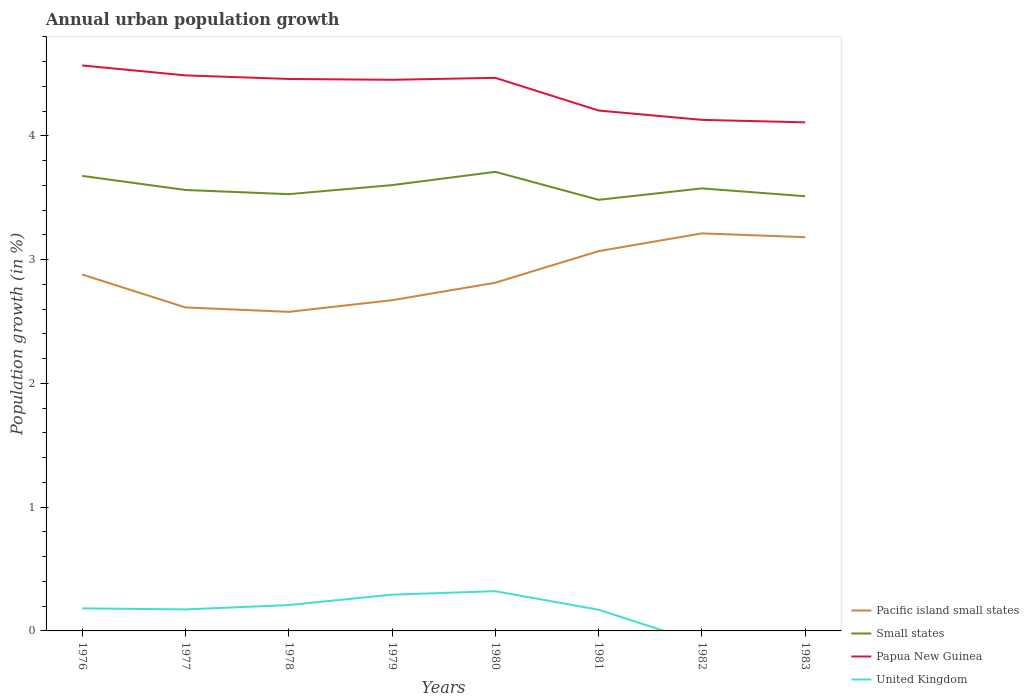How many different coloured lines are there?
Keep it short and to the point. 4. Across all years, what is the maximum percentage of urban population growth in Pacific island small states?
Provide a succinct answer. 2.58. What is the total percentage of urban population growth in Papua New Guinea in the graph?
Ensure brevity in your answer.  0.32. What is the difference between the highest and the second highest percentage of urban population growth in Pacific island small states?
Your response must be concise. 0.63. What is the difference between the highest and the lowest percentage of urban population growth in Papua New Guinea?
Provide a succinct answer. 5. Is the percentage of urban population growth in Pacific island small states strictly greater than the percentage of urban population growth in United Kingdom over the years?
Your answer should be compact. No. How many lines are there?
Your response must be concise. 4. Does the graph contain grids?
Your answer should be very brief. No. Where does the legend appear in the graph?
Provide a short and direct response. Bottom right. How many legend labels are there?
Provide a short and direct response. 4. How are the legend labels stacked?
Make the answer very short. Vertical. What is the title of the graph?
Provide a succinct answer. Annual urban population growth. What is the label or title of the X-axis?
Your answer should be compact. Years. What is the label or title of the Y-axis?
Your answer should be very brief. Population growth (in %). What is the Population growth (in %) in Pacific island small states in 1976?
Your answer should be compact. 2.88. What is the Population growth (in %) of Small states in 1976?
Ensure brevity in your answer.  3.68. What is the Population growth (in %) of Papua New Guinea in 1976?
Provide a succinct answer. 4.57. What is the Population growth (in %) of United Kingdom in 1976?
Make the answer very short. 0.18. What is the Population growth (in %) in Pacific island small states in 1977?
Your answer should be compact. 2.61. What is the Population growth (in %) in Small states in 1977?
Offer a terse response. 3.56. What is the Population growth (in %) of Papua New Guinea in 1977?
Make the answer very short. 4.49. What is the Population growth (in %) in United Kingdom in 1977?
Your answer should be compact. 0.17. What is the Population growth (in %) of Pacific island small states in 1978?
Your response must be concise. 2.58. What is the Population growth (in %) in Small states in 1978?
Your answer should be compact. 3.53. What is the Population growth (in %) in Papua New Guinea in 1978?
Your answer should be very brief. 4.46. What is the Population growth (in %) of United Kingdom in 1978?
Provide a succinct answer. 0.21. What is the Population growth (in %) of Pacific island small states in 1979?
Provide a succinct answer. 2.67. What is the Population growth (in %) of Small states in 1979?
Provide a short and direct response. 3.6. What is the Population growth (in %) of Papua New Guinea in 1979?
Offer a terse response. 4.45. What is the Population growth (in %) of United Kingdom in 1979?
Make the answer very short. 0.29. What is the Population growth (in %) in Pacific island small states in 1980?
Keep it short and to the point. 2.81. What is the Population growth (in %) of Small states in 1980?
Give a very brief answer. 3.71. What is the Population growth (in %) of Papua New Guinea in 1980?
Ensure brevity in your answer.  4.47. What is the Population growth (in %) in United Kingdom in 1980?
Ensure brevity in your answer.  0.32. What is the Population growth (in %) of Pacific island small states in 1981?
Offer a very short reply. 3.07. What is the Population growth (in %) in Small states in 1981?
Give a very brief answer. 3.48. What is the Population growth (in %) in Papua New Guinea in 1981?
Provide a short and direct response. 4.2. What is the Population growth (in %) in United Kingdom in 1981?
Provide a short and direct response. 0.17. What is the Population growth (in %) in Pacific island small states in 1982?
Your answer should be very brief. 3.21. What is the Population growth (in %) of Small states in 1982?
Provide a succinct answer. 3.58. What is the Population growth (in %) in Papua New Guinea in 1982?
Keep it short and to the point. 4.13. What is the Population growth (in %) in Pacific island small states in 1983?
Make the answer very short. 3.18. What is the Population growth (in %) in Small states in 1983?
Provide a succinct answer. 3.51. What is the Population growth (in %) of Papua New Guinea in 1983?
Give a very brief answer. 4.11. Across all years, what is the maximum Population growth (in %) of Pacific island small states?
Offer a very short reply. 3.21. Across all years, what is the maximum Population growth (in %) of Small states?
Offer a very short reply. 3.71. Across all years, what is the maximum Population growth (in %) in Papua New Guinea?
Give a very brief answer. 4.57. Across all years, what is the maximum Population growth (in %) of United Kingdom?
Ensure brevity in your answer.  0.32. Across all years, what is the minimum Population growth (in %) of Pacific island small states?
Your response must be concise. 2.58. Across all years, what is the minimum Population growth (in %) in Small states?
Make the answer very short. 3.48. Across all years, what is the minimum Population growth (in %) of Papua New Guinea?
Your answer should be compact. 4.11. What is the total Population growth (in %) in Pacific island small states in the graph?
Offer a terse response. 23.02. What is the total Population growth (in %) of Small states in the graph?
Provide a short and direct response. 28.65. What is the total Population growth (in %) of Papua New Guinea in the graph?
Keep it short and to the point. 34.88. What is the total Population growth (in %) in United Kingdom in the graph?
Your answer should be very brief. 1.35. What is the difference between the Population growth (in %) of Pacific island small states in 1976 and that in 1977?
Offer a terse response. 0.27. What is the difference between the Population growth (in %) in Small states in 1976 and that in 1977?
Ensure brevity in your answer.  0.11. What is the difference between the Population growth (in %) of Papua New Guinea in 1976 and that in 1977?
Provide a short and direct response. 0.08. What is the difference between the Population growth (in %) of United Kingdom in 1976 and that in 1977?
Your response must be concise. 0.01. What is the difference between the Population growth (in %) of Pacific island small states in 1976 and that in 1978?
Your answer should be very brief. 0.3. What is the difference between the Population growth (in %) in Small states in 1976 and that in 1978?
Your answer should be very brief. 0.15. What is the difference between the Population growth (in %) of Papua New Guinea in 1976 and that in 1978?
Keep it short and to the point. 0.11. What is the difference between the Population growth (in %) of United Kingdom in 1976 and that in 1978?
Provide a short and direct response. -0.03. What is the difference between the Population growth (in %) in Pacific island small states in 1976 and that in 1979?
Provide a succinct answer. 0.21. What is the difference between the Population growth (in %) of Small states in 1976 and that in 1979?
Provide a succinct answer. 0.07. What is the difference between the Population growth (in %) in Papua New Guinea in 1976 and that in 1979?
Offer a terse response. 0.12. What is the difference between the Population growth (in %) of United Kingdom in 1976 and that in 1979?
Your answer should be compact. -0.11. What is the difference between the Population growth (in %) in Pacific island small states in 1976 and that in 1980?
Make the answer very short. 0.07. What is the difference between the Population growth (in %) of Small states in 1976 and that in 1980?
Your answer should be compact. -0.03. What is the difference between the Population growth (in %) in Papua New Guinea in 1976 and that in 1980?
Provide a short and direct response. 0.1. What is the difference between the Population growth (in %) in United Kingdom in 1976 and that in 1980?
Make the answer very short. -0.14. What is the difference between the Population growth (in %) in Pacific island small states in 1976 and that in 1981?
Provide a short and direct response. -0.19. What is the difference between the Population growth (in %) in Small states in 1976 and that in 1981?
Keep it short and to the point. 0.19. What is the difference between the Population growth (in %) of Papua New Guinea in 1976 and that in 1981?
Your answer should be compact. 0.36. What is the difference between the Population growth (in %) of United Kingdom in 1976 and that in 1981?
Keep it short and to the point. 0.01. What is the difference between the Population growth (in %) in Pacific island small states in 1976 and that in 1982?
Make the answer very short. -0.33. What is the difference between the Population growth (in %) in Small states in 1976 and that in 1982?
Make the answer very short. 0.1. What is the difference between the Population growth (in %) in Papua New Guinea in 1976 and that in 1982?
Provide a short and direct response. 0.44. What is the difference between the Population growth (in %) of Pacific island small states in 1976 and that in 1983?
Provide a short and direct response. -0.3. What is the difference between the Population growth (in %) in Small states in 1976 and that in 1983?
Your answer should be very brief. 0.16. What is the difference between the Population growth (in %) of Papua New Guinea in 1976 and that in 1983?
Provide a succinct answer. 0.46. What is the difference between the Population growth (in %) of Pacific island small states in 1977 and that in 1978?
Provide a succinct answer. 0.04. What is the difference between the Population growth (in %) of Small states in 1977 and that in 1978?
Ensure brevity in your answer.  0.03. What is the difference between the Population growth (in %) in Papua New Guinea in 1977 and that in 1978?
Your answer should be very brief. 0.03. What is the difference between the Population growth (in %) of United Kingdom in 1977 and that in 1978?
Your response must be concise. -0.04. What is the difference between the Population growth (in %) of Pacific island small states in 1977 and that in 1979?
Your answer should be very brief. -0.06. What is the difference between the Population growth (in %) of Small states in 1977 and that in 1979?
Offer a terse response. -0.04. What is the difference between the Population growth (in %) of Papua New Guinea in 1977 and that in 1979?
Keep it short and to the point. 0.04. What is the difference between the Population growth (in %) of United Kingdom in 1977 and that in 1979?
Give a very brief answer. -0.12. What is the difference between the Population growth (in %) in Pacific island small states in 1977 and that in 1980?
Offer a very short reply. -0.2. What is the difference between the Population growth (in %) of Small states in 1977 and that in 1980?
Make the answer very short. -0.15. What is the difference between the Population growth (in %) of Papua New Guinea in 1977 and that in 1980?
Offer a very short reply. 0.02. What is the difference between the Population growth (in %) in United Kingdom in 1977 and that in 1980?
Provide a short and direct response. -0.15. What is the difference between the Population growth (in %) in Pacific island small states in 1977 and that in 1981?
Provide a short and direct response. -0.46. What is the difference between the Population growth (in %) in Small states in 1977 and that in 1981?
Provide a short and direct response. 0.08. What is the difference between the Population growth (in %) of Papua New Guinea in 1977 and that in 1981?
Offer a very short reply. 0.28. What is the difference between the Population growth (in %) of United Kingdom in 1977 and that in 1981?
Your answer should be compact. 0. What is the difference between the Population growth (in %) in Pacific island small states in 1977 and that in 1982?
Offer a very short reply. -0.6. What is the difference between the Population growth (in %) of Small states in 1977 and that in 1982?
Give a very brief answer. -0.01. What is the difference between the Population growth (in %) in Papua New Guinea in 1977 and that in 1982?
Your answer should be very brief. 0.36. What is the difference between the Population growth (in %) of Pacific island small states in 1977 and that in 1983?
Your answer should be compact. -0.57. What is the difference between the Population growth (in %) of Small states in 1977 and that in 1983?
Ensure brevity in your answer.  0.05. What is the difference between the Population growth (in %) of Papua New Guinea in 1977 and that in 1983?
Your answer should be compact. 0.38. What is the difference between the Population growth (in %) in Pacific island small states in 1978 and that in 1979?
Your answer should be very brief. -0.09. What is the difference between the Population growth (in %) in Small states in 1978 and that in 1979?
Ensure brevity in your answer.  -0.07. What is the difference between the Population growth (in %) of Papua New Guinea in 1978 and that in 1979?
Ensure brevity in your answer.  0.01. What is the difference between the Population growth (in %) in United Kingdom in 1978 and that in 1979?
Offer a very short reply. -0.08. What is the difference between the Population growth (in %) of Pacific island small states in 1978 and that in 1980?
Keep it short and to the point. -0.24. What is the difference between the Population growth (in %) of Small states in 1978 and that in 1980?
Provide a short and direct response. -0.18. What is the difference between the Population growth (in %) of Papua New Guinea in 1978 and that in 1980?
Offer a terse response. -0.01. What is the difference between the Population growth (in %) of United Kingdom in 1978 and that in 1980?
Make the answer very short. -0.11. What is the difference between the Population growth (in %) of Pacific island small states in 1978 and that in 1981?
Keep it short and to the point. -0.49. What is the difference between the Population growth (in %) in Small states in 1978 and that in 1981?
Provide a succinct answer. 0.05. What is the difference between the Population growth (in %) of Papua New Guinea in 1978 and that in 1981?
Make the answer very short. 0.26. What is the difference between the Population growth (in %) in United Kingdom in 1978 and that in 1981?
Give a very brief answer. 0.04. What is the difference between the Population growth (in %) of Pacific island small states in 1978 and that in 1982?
Make the answer very short. -0.63. What is the difference between the Population growth (in %) of Small states in 1978 and that in 1982?
Provide a succinct answer. -0.05. What is the difference between the Population growth (in %) in Papua New Guinea in 1978 and that in 1982?
Give a very brief answer. 0.33. What is the difference between the Population growth (in %) in Pacific island small states in 1978 and that in 1983?
Your answer should be very brief. -0.6. What is the difference between the Population growth (in %) of Small states in 1978 and that in 1983?
Give a very brief answer. 0.02. What is the difference between the Population growth (in %) in Papua New Guinea in 1978 and that in 1983?
Keep it short and to the point. 0.35. What is the difference between the Population growth (in %) in Pacific island small states in 1979 and that in 1980?
Provide a succinct answer. -0.14. What is the difference between the Population growth (in %) of Small states in 1979 and that in 1980?
Your response must be concise. -0.11. What is the difference between the Population growth (in %) of Papua New Guinea in 1979 and that in 1980?
Offer a very short reply. -0.02. What is the difference between the Population growth (in %) in United Kingdom in 1979 and that in 1980?
Your answer should be compact. -0.03. What is the difference between the Population growth (in %) of Pacific island small states in 1979 and that in 1981?
Provide a succinct answer. -0.4. What is the difference between the Population growth (in %) in Small states in 1979 and that in 1981?
Offer a very short reply. 0.12. What is the difference between the Population growth (in %) of Papua New Guinea in 1979 and that in 1981?
Offer a very short reply. 0.25. What is the difference between the Population growth (in %) in United Kingdom in 1979 and that in 1981?
Keep it short and to the point. 0.12. What is the difference between the Population growth (in %) of Pacific island small states in 1979 and that in 1982?
Ensure brevity in your answer.  -0.54. What is the difference between the Population growth (in %) of Small states in 1979 and that in 1982?
Offer a terse response. 0.03. What is the difference between the Population growth (in %) of Papua New Guinea in 1979 and that in 1982?
Keep it short and to the point. 0.32. What is the difference between the Population growth (in %) of Pacific island small states in 1979 and that in 1983?
Give a very brief answer. -0.51. What is the difference between the Population growth (in %) of Small states in 1979 and that in 1983?
Give a very brief answer. 0.09. What is the difference between the Population growth (in %) of Papua New Guinea in 1979 and that in 1983?
Offer a very short reply. 0.34. What is the difference between the Population growth (in %) in Pacific island small states in 1980 and that in 1981?
Your answer should be compact. -0.26. What is the difference between the Population growth (in %) of Small states in 1980 and that in 1981?
Provide a short and direct response. 0.23. What is the difference between the Population growth (in %) in Papua New Guinea in 1980 and that in 1981?
Ensure brevity in your answer.  0.26. What is the difference between the Population growth (in %) in United Kingdom in 1980 and that in 1981?
Your answer should be very brief. 0.15. What is the difference between the Population growth (in %) in Pacific island small states in 1980 and that in 1982?
Provide a succinct answer. -0.4. What is the difference between the Population growth (in %) of Small states in 1980 and that in 1982?
Provide a succinct answer. 0.13. What is the difference between the Population growth (in %) in Papua New Guinea in 1980 and that in 1982?
Ensure brevity in your answer.  0.34. What is the difference between the Population growth (in %) in Pacific island small states in 1980 and that in 1983?
Ensure brevity in your answer.  -0.37. What is the difference between the Population growth (in %) in Small states in 1980 and that in 1983?
Offer a terse response. 0.2. What is the difference between the Population growth (in %) of Papua New Guinea in 1980 and that in 1983?
Your response must be concise. 0.36. What is the difference between the Population growth (in %) of Pacific island small states in 1981 and that in 1982?
Offer a very short reply. -0.14. What is the difference between the Population growth (in %) in Small states in 1981 and that in 1982?
Make the answer very short. -0.09. What is the difference between the Population growth (in %) in Papua New Guinea in 1981 and that in 1982?
Offer a very short reply. 0.08. What is the difference between the Population growth (in %) of Pacific island small states in 1981 and that in 1983?
Provide a succinct answer. -0.11. What is the difference between the Population growth (in %) of Small states in 1981 and that in 1983?
Your answer should be compact. -0.03. What is the difference between the Population growth (in %) in Papua New Guinea in 1981 and that in 1983?
Ensure brevity in your answer.  0.1. What is the difference between the Population growth (in %) of Pacific island small states in 1982 and that in 1983?
Provide a succinct answer. 0.03. What is the difference between the Population growth (in %) of Small states in 1982 and that in 1983?
Make the answer very short. 0.06. What is the difference between the Population growth (in %) in Papua New Guinea in 1982 and that in 1983?
Offer a very short reply. 0.02. What is the difference between the Population growth (in %) of Pacific island small states in 1976 and the Population growth (in %) of Small states in 1977?
Offer a very short reply. -0.68. What is the difference between the Population growth (in %) of Pacific island small states in 1976 and the Population growth (in %) of Papua New Guinea in 1977?
Provide a succinct answer. -1.61. What is the difference between the Population growth (in %) of Pacific island small states in 1976 and the Population growth (in %) of United Kingdom in 1977?
Offer a terse response. 2.71. What is the difference between the Population growth (in %) in Small states in 1976 and the Population growth (in %) in Papua New Guinea in 1977?
Your answer should be very brief. -0.81. What is the difference between the Population growth (in %) in Small states in 1976 and the Population growth (in %) in United Kingdom in 1977?
Your answer should be compact. 3.5. What is the difference between the Population growth (in %) of Papua New Guinea in 1976 and the Population growth (in %) of United Kingdom in 1977?
Your response must be concise. 4.4. What is the difference between the Population growth (in %) of Pacific island small states in 1976 and the Population growth (in %) of Small states in 1978?
Give a very brief answer. -0.65. What is the difference between the Population growth (in %) of Pacific island small states in 1976 and the Population growth (in %) of Papua New Guinea in 1978?
Your response must be concise. -1.58. What is the difference between the Population growth (in %) of Pacific island small states in 1976 and the Population growth (in %) of United Kingdom in 1978?
Your answer should be very brief. 2.67. What is the difference between the Population growth (in %) in Small states in 1976 and the Population growth (in %) in Papua New Guinea in 1978?
Your answer should be compact. -0.78. What is the difference between the Population growth (in %) of Small states in 1976 and the Population growth (in %) of United Kingdom in 1978?
Your answer should be compact. 3.47. What is the difference between the Population growth (in %) of Papua New Guinea in 1976 and the Population growth (in %) of United Kingdom in 1978?
Offer a very short reply. 4.36. What is the difference between the Population growth (in %) in Pacific island small states in 1976 and the Population growth (in %) in Small states in 1979?
Provide a short and direct response. -0.72. What is the difference between the Population growth (in %) in Pacific island small states in 1976 and the Population growth (in %) in Papua New Guinea in 1979?
Your response must be concise. -1.57. What is the difference between the Population growth (in %) in Pacific island small states in 1976 and the Population growth (in %) in United Kingdom in 1979?
Your answer should be compact. 2.59. What is the difference between the Population growth (in %) in Small states in 1976 and the Population growth (in %) in Papua New Guinea in 1979?
Your answer should be compact. -0.78. What is the difference between the Population growth (in %) in Small states in 1976 and the Population growth (in %) in United Kingdom in 1979?
Keep it short and to the point. 3.38. What is the difference between the Population growth (in %) of Papua New Guinea in 1976 and the Population growth (in %) of United Kingdom in 1979?
Offer a terse response. 4.28. What is the difference between the Population growth (in %) of Pacific island small states in 1976 and the Population growth (in %) of Small states in 1980?
Ensure brevity in your answer.  -0.83. What is the difference between the Population growth (in %) of Pacific island small states in 1976 and the Population growth (in %) of Papua New Guinea in 1980?
Ensure brevity in your answer.  -1.59. What is the difference between the Population growth (in %) in Pacific island small states in 1976 and the Population growth (in %) in United Kingdom in 1980?
Your answer should be very brief. 2.56. What is the difference between the Population growth (in %) in Small states in 1976 and the Population growth (in %) in Papua New Guinea in 1980?
Your answer should be very brief. -0.79. What is the difference between the Population growth (in %) in Small states in 1976 and the Population growth (in %) in United Kingdom in 1980?
Provide a succinct answer. 3.36. What is the difference between the Population growth (in %) of Papua New Guinea in 1976 and the Population growth (in %) of United Kingdom in 1980?
Ensure brevity in your answer.  4.25. What is the difference between the Population growth (in %) of Pacific island small states in 1976 and the Population growth (in %) of Small states in 1981?
Your answer should be compact. -0.6. What is the difference between the Population growth (in %) of Pacific island small states in 1976 and the Population growth (in %) of Papua New Guinea in 1981?
Ensure brevity in your answer.  -1.32. What is the difference between the Population growth (in %) in Pacific island small states in 1976 and the Population growth (in %) in United Kingdom in 1981?
Your answer should be very brief. 2.71. What is the difference between the Population growth (in %) in Small states in 1976 and the Population growth (in %) in Papua New Guinea in 1981?
Make the answer very short. -0.53. What is the difference between the Population growth (in %) in Small states in 1976 and the Population growth (in %) in United Kingdom in 1981?
Ensure brevity in your answer.  3.51. What is the difference between the Population growth (in %) of Papua New Guinea in 1976 and the Population growth (in %) of United Kingdom in 1981?
Provide a succinct answer. 4.4. What is the difference between the Population growth (in %) of Pacific island small states in 1976 and the Population growth (in %) of Small states in 1982?
Your response must be concise. -0.7. What is the difference between the Population growth (in %) of Pacific island small states in 1976 and the Population growth (in %) of Papua New Guinea in 1982?
Your response must be concise. -1.25. What is the difference between the Population growth (in %) of Small states in 1976 and the Population growth (in %) of Papua New Guinea in 1982?
Your response must be concise. -0.45. What is the difference between the Population growth (in %) of Pacific island small states in 1976 and the Population growth (in %) of Small states in 1983?
Provide a succinct answer. -0.63. What is the difference between the Population growth (in %) in Pacific island small states in 1976 and the Population growth (in %) in Papua New Guinea in 1983?
Provide a short and direct response. -1.23. What is the difference between the Population growth (in %) in Small states in 1976 and the Population growth (in %) in Papua New Guinea in 1983?
Keep it short and to the point. -0.43. What is the difference between the Population growth (in %) of Pacific island small states in 1977 and the Population growth (in %) of Small states in 1978?
Provide a short and direct response. -0.92. What is the difference between the Population growth (in %) of Pacific island small states in 1977 and the Population growth (in %) of Papua New Guinea in 1978?
Offer a terse response. -1.85. What is the difference between the Population growth (in %) of Pacific island small states in 1977 and the Population growth (in %) of United Kingdom in 1978?
Your answer should be compact. 2.4. What is the difference between the Population growth (in %) of Small states in 1977 and the Population growth (in %) of Papua New Guinea in 1978?
Your response must be concise. -0.9. What is the difference between the Population growth (in %) of Small states in 1977 and the Population growth (in %) of United Kingdom in 1978?
Provide a succinct answer. 3.35. What is the difference between the Population growth (in %) of Papua New Guinea in 1977 and the Population growth (in %) of United Kingdom in 1978?
Ensure brevity in your answer.  4.28. What is the difference between the Population growth (in %) in Pacific island small states in 1977 and the Population growth (in %) in Small states in 1979?
Ensure brevity in your answer.  -0.99. What is the difference between the Population growth (in %) in Pacific island small states in 1977 and the Population growth (in %) in Papua New Guinea in 1979?
Provide a short and direct response. -1.84. What is the difference between the Population growth (in %) in Pacific island small states in 1977 and the Population growth (in %) in United Kingdom in 1979?
Give a very brief answer. 2.32. What is the difference between the Population growth (in %) in Small states in 1977 and the Population growth (in %) in Papua New Guinea in 1979?
Offer a very short reply. -0.89. What is the difference between the Population growth (in %) in Small states in 1977 and the Population growth (in %) in United Kingdom in 1979?
Provide a succinct answer. 3.27. What is the difference between the Population growth (in %) in Papua New Guinea in 1977 and the Population growth (in %) in United Kingdom in 1979?
Provide a succinct answer. 4.2. What is the difference between the Population growth (in %) of Pacific island small states in 1977 and the Population growth (in %) of Small states in 1980?
Keep it short and to the point. -1.1. What is the difference between the Population growth (in %) in Pacific island small states in 1977 and the Population growth (in %) in Papua New Guinea in 1980?
Keep it short and to the point. -1.86. What is the difference between the Population growth (in %) in Pacific island small states in 1977 and the Population growth (in %) in United Kingdom in 1980?
Provide a short and direct response. 2.29. What is the difference between the Population growth (in %) in Small states in 1977 and the Population growth (in %) in Papua New Guinea in 1980?
Offer a very short reply. -0.91. What is the difference between the Population growth (in %) of Small states in 1977 and the Population growth (in %) of United Kingdom in 1980?
Your response must be concise. 3.24. What is the difference between the Population growth (in %) of Papua New Guinea in 1977 and the Population growth (in %) of United Kingdom in 1980?
Give a very brief answer. 4.17. What is the difference between the Population growth (in %) in Pacific island small states in 1977 and the Population growth (in %) in Small states in 1981?
Your answer should be very brief. -0.87. What is the difference between the Population growth (in %) of Pacific island small states in 1977 and the Population growth (in %) of Papua New Guinea in 1981?
Provide a succinct answer. -1.59. What is the difference between the Population growth (in %) of Pacific island small states in 1977 and the Population growth (in %) of United Kingdom in 1981?
Give a very brief answer. 2.44. What is the difference between the Population growth (in %) of Small states in 1977 and the Population growth (in %) of Papua New Guinea in 1981?
Keep it short and to the point. -0.64. What is the difference between the Population growth (in %) of Small states in 1977 and the Population growth (in %) of United Kingdom in 1981?
Offer a very short reply. 3.39. What is the difference between the Population growth (in %) of Papua New Guinea in 1977 and the Population growth (in %) of United Kingdom in 1981?
Offer a terse response. 4.32. What is the difference between the Population growth (in %) in Pacific island small states in 1977 and the Population growth (in %) in Small states in 1982?
Keep it short and to the point. -0.96. What is the difference between the Population growth (in %) of Pacific island small states in 1977 and the Population growth (in %) of Papua New Guinea in 1982?
Your response must be concise. -1.52. What is the difference between the Population growth (in %) of Small states in 1977 and the Population growth (in %) of Papua New Guinea in 1982?
Provide a succinct answer. -0.57. What is the difference between the Population growth (in %) of Pacific island small states in 1977 and the Population growth (in %) of Small states in 1983?
Ensure brevity in your answer.  -0.9. What is the difference between the Population growth (in %) of Pacific island small states in 1977 and the Population growth (in %) of Papua New Guinea in 1983?
Keep it short and to the point. -1.5. What is the difference between the Population growth (in %) in Small states in 1977 and the Population growth (in %) in Papua New Guinea in 1983?
Your answer should be very brief. -0.55. What is the difference between the Population growth (in %) in Pacific island small states in 1978 and the Population growth (in %) in Small states in 1979?
Your answer should be compact. -1.02. What is the difference between the Population growth (in %) of Pacific island small states in 1978 and the Population growth (in %) of Papua New Guinea in 1979?
Offer a very short reply. -1.88. What is the difference between the Population growth (in %) of Pacific island small states in 1978 and the Population growth (in %) of United Kingdom in 1979?
Offer a terse response. 2.29. What is the difference between the Population growth (in %) in Small states in 1978 and the Population growth (in %) in Papua New Guinea in 1979?
Your response must be concise. -0.92. What is the difference between the Population growth (in %) of Small states in 1978 and the Population growth (in %) of United Kingdom in 1979?
Make the answer very short. 3.24. What is the difference between the Population growth (in %) of Papua New Guinea in 1978 and the Population growth (in %) of United Kingdom in 1979?
Your answer should be compact. 4.17. What is the difference between the Population growth (in %) in Pacific island small states in 1978 and the Population growth (in %) in Small states in 1980?
Keep it short and to the point. -1.13. What is the difference between the Population growth (in %) in Pacific island small states in 1978 and the Population growth (in %) in Papua New Guinea in 1980?
Your response must be concise. -1.89. What is the difference between the Population growth (in %) in Pacific island small states in 1978 and the Population growth (in %) in United Kingdom in 1980?
Keep it short and to the point. 2.26. What is the difference between the Population growth (in %) in Small states in 1978 and the Population growth (in %) in Papua New Guinea in 1980?
Your answer should be compact. -0.94. What is the difference between the Population growth (in %) of Small states in 1978 and the Population growth (in %) of United Kingdom in 1980?
Keep it short and to the point. 3.21. What is the difference between the Population growth (in %) of Papua New Guinea in 1978 and the Population growth (in %) of United Kingdom in 1980?
Provide a succinct answer. 4.14. What is the difference between the Population growth (in %) of Pacific island small states in 1978 and the Population growth (in %) of Small states in 1981?
Provide a short and direct response. -0.91. What is the difference between the Population growth (in %) in Pacific island small states in 1978 and the Population growth (in %) in Papua New Guinea in 1981?
Your response must be concise. -1.63. What is the difference between the Population growth (in %) of Pacific island small states in 1978 and the Population growth (in %) of United Kingdom in 1981?
Provide a short and direct response. 2.41. What is the difference between the Population growth (in %) in Small states in 1978 and the Population growth (in %) in Papua New Guinea in 1981?
Provide a short and direct response. -0.68. What is the difference between the Population growth (in %) of Small states in 1978 and the Population growth (in %) of United Kingdom in 1981?
Make the answer very short. 3.36. What is the difference between the Population growth (in %) in Papua New Guinea in 1978 and the Population growth (in %) in United Kingdom in 1981?
Provide a short and direct response. 4.29. What is the difference between the Population growth (in %) of Pacific island small states in 1978 and the Population growth (in %) of Small states in 1982?
Your answer should be very brief. -1. What is the difference between the Population growth (in %) of Pacific island small states in 1978 and the Population growth (in %) of Papua New Guinea in 1982?
Give a very brief answer. -1.55. What is the difference between the Population growth (in %) of Small states in 1978 and the Population growth (in %) of Papua New Guinea in 1982?
Your response must be concise. -0.6. What is the difference between the Population growth (in %) of Pacific island small states in 1978 and the Population growth (in %) of Small states in 1983?
Give a very brief answer. -0.93. What is the difference between the Population growth (in %) of Pacific island small states in 1978 and the Population growth (in %) of Papua New Guinea in 1983?
Make the answer very short. -1.53. What is the difference between the Population growth (in %) of Small states in 1978 and the Population growth (in %) of Papua New Guinea in 1983?
Provide a short and direct response. -0.58. What is the difference between the Population growth (in %) in Pacific island small states in 1979 and the Population growth (in %) in Small states in 1980?
Make the answer very short. -1.04. What is the difference between the Population growth (in %) in Pacific island small states in 1979 and the Population growth (in %) in Papua New Guinea in 1980?
Make the answer very short. -1.8. What is the difference between the Population growth (in %) of Pacific island small states in 1979 and the Population growth (in %) of United Kingdom in 1980?
Offer a very short reply. 2.35. What is the difference between the Population growth (in %) of Small states in 1979 and the Population growth (in %) of Papua New Guinea in 1980?
Your answer should be compact. -0.87. What is the difference between the Population growth (in %) in Small states in 1979 and the Population growth (in %) in United Kingdom in 1980?
Give a very brief answer. 3.28. What is the difference between the Population growth (in %) of Papua New Guinea in 1979 and the Population growth (in %) of United Kingdom in 1980?
Make the answer very short. 4.13. What is the difference between the Population growth (in %) in Pacific island small states in 1979 and the Population growth (in %) in Small states in 1981?
Provide a short and direct response. -0.81. What is the difference between the Population growth (in %) of Pacific island small states in 1979 and the Population growth (in %) of Papua New Guinea in 1981?
Your response must be concise. -1.53. What is the difference between the Population growth (in %) in Pacific island small states in 1979 and the Population growth (in %) in United Kingdom in 1981?
Offer a terse response. 2.5. What is the difference between the Population growth (in %) of Small states in 1979 and the Population growth (in %) of Papua New Guinea in 1981?
Make the answer very short. -0.6. What is the difference between the Population growth (in %) in Small states in 1979 and the Population growth (in %) in United Kingdom in 1981?
Offer a very short reply. 3.43. What is the difference between the Population growth (in %) in Papua New Guinea in 1979 and the Population growth (in %) in United Kingdom in 1981?
Make the answer very short. 4.28. What is the difference between the Population growth (in %) in Pacific island small states in 1979 and the Population growth (in %) in Small states in 1982?
Provide a short and direct response. -0.9. What is the difference between the Population growth (in %) in Pacific island small states in 1979 and the Population growth (in %) in Papua New Guinea in 1982?
Your answer should be very brief. -1.46. What is the difference between the Population growth (in %) in Small states in 1979 and the Population growth (in %) in Papua New Guinea in 1982?
Your response must be concise. -0.53. What is the difference between the Population growth (in %) in Pacific island small states in 1979 and the Population growth (in %) in Small states in 1983?
Keep it short and to the point. -0.84. What is the difference between the Population growth (in %) of Pacific island small states in 1979 and the Population growth (in %) of Papua New Guinea in 1983?
Offer a very short reply. -1.44. What is the difference between the Population growth (in %) in Small states in 1979 and the Population growth (in %) in Papua New Guinea in 1983?
Provide a succinct answer. -0.51. What is the difference between the Population growth (in %) of Pacific island small states in 1980 and the Population growth (in %) of Small states in 1981?
Make the answer very short. -0.67. What is the difference between the Population growth (in %) in Pacific island small states in 1980 and the Population growth (in %) in Papua New Guinea in 1981?
Provide a succinct answer. -1.39. What is the difference between the Population growth (in %) in Pacific island small states in 1980 and the Population growth (in %) in United Kingdom in 1981?
Your answer should be very brief. 2.64. What is the difference between the Population growth (in %) of Small states in 1980 and the Population growth (in %) of Papua New Guinea in 1981?
Make the answer very short. -0.5. What is the difference between the Population growth (in %) in Small states in 1980 and the Population growth (in %) in United Kingdom in 1981?
Your answer should be compact. 3.54. What is the difference between the Population growth (in %) of Papua New Guinea in 1980 and the Population growth (in %) of United Kingdom in 1981?
Offer a terse response. 4.3. What is the difference between the Population growth (in %) in Pacific island small states in 1980 and the Population growth (in %) in Small states in 1982?
Offer a very short reply. -0.76. What is the difference between the Population growth (in %) of Pacific island small states in 1980 and the Population growth (in %) of Papua New Guinea in 1982?
Keep it short and to the point. -1.32. What is the difference between the Population growth (in %) of Small states in 1980 and the Population growth (in %) of Papua New Guinea in 1982?
Keep it short and to the point. -0.42. What is the difference between the Population growth (in %) of Pacific island small states in 1980 and the Population growth (in %) of Small states in 1983?
Provide a short and direct response. -0.7. What is the difference between the Population growth (in %) of Pacific island small states in 1980 and the Population growth (in %) of Papua New Guinea in 1983?
Provide a succinct answer. -1.3. What is the difference between the Population growth (in %) in Small states in 1980 and the Population growth (in %) in Papua New Guinea in 1983?
Your answer should be compact. -0.4. What is the difference between the Population growth (in %) of Pacific island small states in 1981 and the Population growth (in %) of Small states in 1982?
Offer a terse response. -0.51. What is the difference between the Population growth (in %) in Pacific island small states in 1981 and the Population growth (in %) in Papua New Guinea in 1982?
Provide a succinct answer. -1.06. What is the difference between the Population growth (in %) of Small states in 1981 and the Population growth (in %) of Papua New Guinea in 1982?
Your response must be concise. -0.65. What is the difference between the Population growth (in %) in Pacific island small states in 1981 and the Population growth (in %) in Small states in 1983?
Your answer should be compact. -0.44. What is the difference between the Population growth (in %) in Pacific island small states in 1981 and the Population growth (in %) in Papua New Guinea in 1983?
Offer a very short reply. -1.04. What is the difference between the Population growth (in %) in Small states in 1981 and the Population growth (in %) in Papua New Guinea in 1983?
Give a very brief answer. -0.63. What is the difference between the Population growth (in %) of Pacific island small states in 1982 and the Population growth (in %) of Small states in 1983?
Your answer should be very brief. -0.3. What is the difference between the Population growth (in %) of Pacific island small states in 1982 and the Population growth (in %) of Papua New Guinea in 1983?
Give a very brief answer. -0.9. What is the difference between the Population growth (in %) of Small states in 1982 and the Population growth (in %) of Papua New Guinea in 1983?
Give a very brief answer. -0.53. What is the average Population growth (in %) in Pacific island small states per year?
Your answer should be compact. 2.88. What is the average Population growth (in %) in Small states per year?
Ensure brevity in your answer.  3.58. What is the average Population growth (in %) in Papua New Guinea per year?
Provide a short and direct response. 4.36. What is the average Population growth (in %) in United Kingdom per year?
Offer a very short reply. 0.17. In the year 1976, what is the difference between the Population growth (in %) in Pacific island small states and Population growth (in %) in Small states?
Offer a terse response. -0.8. In the year 1976, what is the difference between the Population growth (in %) in Pacific island small states and Population growth (in %) in Papua New Guinea?
Give a very brief answer. -1.69. In the year 1976, what is the difference between the Population growth (in %) of Pacific island small states and Population growth (in %) of United Kingdom?
Make the answer very short. 2.7. In the year 1976, what is the difference between the Population growth (in %) in Small states and Population growth (in %) in Papua New Guinea?
Your response must be concise. -0.89. In the year 1976, what is the difference between the Population growth (in %) in Small states and Population growth (in %) in United Kingdom?
Give a very brief answer. 3.49. In the year 1976, what is the difference between the Population growth (in %) in Papua New Guinea and Population growth (in %) in United Kingdom?
Provide a succinct answer. 4.39. In the year 1977, what is the difference between the Population growth (in %) of Pacific island small states and Population growth (in %) of Small states?
Keep it short and to the point. -0.95. In the year 1977, what is the difference between the Population growth (in %) of Pacific island small states and Population growth (in %) of Papua New Guinea?
Your answer should be compact. -1.88. In the year 1977, what is the difference between the Population growth (in %) of Pacific island small states and Population growth (in %) of United Kingdom?
Provide a short and direct response. 2.44. In the year 1977, what is the difference between the Population growth (in %) in Small states and Population growth (in %) in Papua New Guinea?
Your answer should be very brief. -0.93. In the year 1977, what is the difference between the Population growth (in %) in Small states and Population growth (in %) in United Kingdom?
Offer a terse response. 3.39. In the year 1977, what is the difference between the Population growth (in %) in Papua New Guinea and Population growth (in %) in United Kingdom?
Ensure brevity in your answer.  4.32. In the year 1978, what is the difference between the Population growth (in %) in Pacific island small states and Population growth (in %) in Small states?
Offer a very short reply. -0.95. In the year 1978, what is the difference between the Population growth (in %) in Pacific island small states and Population growth (in %) in Papua New Guinea?
Make the answer very short. -1.88. In the year 1978, what is the difference between the Population growth (in %) in Pacific island small states and Population growth (in %) in United Kingdom?
Offer a terse response. 2.37. In the year 1978, what is the difference between the Population growth (in %) in Small states and Population growth (in %) in Papua New Guinea?
Your answer should be very brief. -0.93. In the year 1978, what is the difference between the Population growth (in %) of Small states and Population growth (in %) of United Kingdom?
Provide a short and direct response. 3.32. In the year 1978, what is the difference between the Population growth (in %) in Papua New Guinea and Population growth (in %) in United Kingdom?
Offer a terse response. 4.25. In the year 1979, what is the difference between the Population growth (in %) of Pacific island small states and Population growth (in %) of Small states?
Your answer should be very brief. -0.93. In the year 1979, what is the difference between the Population growth (in %) in Pacific island small states and Population growth (in %) in Papua New Guinea?
Your answer should be very brief. -1.78. In the year 1979, what is the difference between the Population growth (in %) in Pacific island small states and Population growth (in %) in United Kingdom?
Give a very brief answer. 2.38. In the year 1979, what is the difference between the Population growth (in %) in Small states and Population growth (in %) in Papua New Guinea?
Make the answer very short. -0.85. In the year 1979, what is the difference between the Population growth (in %) of Small states and Population growth (in %) of United Kingdom?
Your response must be concise. 3.31. In the year 1979, what is the difference between the Population growth (in %) in Papua New Guinea and Population growth (in %) in United Kingdom?
Provide a succinct answer. 4.16. In the year 1980, what is the difference between the Population growth (in %) of Pacific island small states and Population growth (in %) of Small states?
Offer a very short reply. -0.9. In the year 1980, what is the difference between the Population growth (in %) in Pacific island small states and Population growth (in %) in Papua New Guinea?
Keep it short and to the point. -1.66. In the year 1980, what is the difference between the Population growth (in %) in Pacific island small states and Population growth (in %) in United Kingdom?
Your response must be concise. 2.49. In the year 1980, what is the difference between the Population growth (in %) of Small states and Population growth (in %) of Papua New Guinea?
Give a very brief answer. -0.76. In the year 1980, what is the difference between the Population growth (in %) in Small states and Population growth (in %) in United Kingdom?
Your response must be concise. 3.39. In the year 1980, what is the difference between the Population growth (in %) in Papua New Guinea and Population growth (in %) in United Kingdom?
Your answer should be compact. 4.15. In the year 1981, what is the difference between the Population growth (in %) in Pacific island small states and Population growth (in %) in Small states?
Ensure brevity in your answer.  -0.41. In the year 1981, what is the difference between the Population growth (in %) in Pacific island small states and Population growth (in %) in Papua New Guinea?
Make the answer very short. -1.14. In the year 1981, what is the difference between the Population growth (in %) in Pacific island small states and Population growth (in %) in United Kingdom?
Ensure brevity in your answer.  2.9. In the year 1981, what is the difference between the Population growth (in %) of Small states and Population growth (in %) of Papua New Guinea?
Make the answer very short. -0.72. In the year 1981, what is the difference between the Population growth (in %) of Small states and Population growth (in %) of United Kingdom?
Offer a terse response. 3.31. In the year 1981, what is the difference between the Population growth (in %) of Papua New Guinea and Population growth (in %) of United Kingdom?
Provide a short and direct response. 4.03. In the year 1982, what is the difference between the Population growth (in %) of Pacific island small states and Population growth (in %) of Small states?
Your response must be concise. -0.36. In the year 1982, what is the difference between the Population growth (in %) of Pacific island small states and Population growth (in %) of Papua New Guinea?
Make the answer very short. -0.92. In the year 1982, what is the difference between the Population growth (in %) in Small states and Population growth (in %) in Papua New Guinea?
Offer a very short reply. -0.55. In the year 1983, what is the difference between the Population growth (in %) of Pacific island small states and Population growth (in %) of Small states?
Ensure brevity in your answer.  -0.33. In the year 1983, what is the difference between the Population growth (in %) of Pacific island small states and Population growth (in %) of Papua New Guinea?
Offer a very short reply. -0.93. In the year 1983, what is the difference between the Population growth (in %) in Small states and Population growth (in %) in Papua New Guinea?
Offer a terse response. -0.6. What is the ratio of the Population growth (in %) of Pacific island small states in 1976 to that in 1977?
Provide a succinct answer. 1.1. What is the ratio of the Population growth (in %) in Small states in 1976 to that in 1977?
Your response must be concise. 1.03. What is the ratio of the Population growth (in %) in Papua New Guinea in 1976 to that in 1977?
Ensure brevity in your answer.  1.02. What is the ratio of the Population growth (in %) in United Kingdom in 1976 to that in 1977?
Give a very brief answer. 1.05. What is the ratio of the Population growth (in %) in Pacific island small states in 1976 to that in 1978?
Offer a terse response. 1.12. What is the ratio of the Population growth (in %) in Small states in 1976 to that in 1978?
Ensure brevity in your answer.  1.04. What is the ratio of the Population growth (in %) of Papua New Guinea in 1976 to that in 1978?
Your answer should be compact. 1.02. What is the ratio of the Population growth (in %) in United Kingdom in 1976 to that in 1978?
Your response must be concise. 0.87. What is the ratio of the Population growth (in %) of Pacific island small states in 1976 to that in 1979?
Provide a succinct answer. 1.08. What is the ratio of the Population growth (in %) of Small states in 1976 to that in 1979?
Offer a very short reply. 1.02. What is the ratio of the Population growth (in %) in Papua New Guinea in 1976 to that in 1979?
Provide a succinct answer. 1.03. What is the ratio of the Population growth (in %) of United Kingdom in 1976 to that in 1979?
Keep it short and to the point. 0.62. What is the ratio of the Population growth (in %) in Pacific island small states in 1976 to that in 1980?
Make the answer very short. 1.02. What is the ratio of the Population growth (in %) in Papua New Guinea in 1976 to that in 1980?
Ensure brevity in your answer.  1.02. What is the ratio of the Population growth (in %) in United Kingdom in 1976 to that in 1980?
Offer a very short reply. 0.57. What is the ratio of the Population growth (in %) of Pacific island small states in 1976 to that in 1981?
Your answer should be compact. 0.94. What is the ratio of the Population growth (in %) in Small states in 1976 to that in 1981?
Your response must be concise. 1.06. What is the ratio of the Population growth (in %) of Papua New Guinea in 1976 to that in 1981?
Offer a very short reply. 1.09. What is the ratio of the Population growth (in %) of United Kingdom in 1976 to that in 1981?
Offer a terse response. 1.07. What is the ratio of the Population growth (in %) in Pacific island small states in 1976 to that in 1982?
Give a very brief answer. 0.9. What is the ratio of the Population growth (in %) in Small states in 1976 to that in 1982?
Keep it short and to the point. 1.03. What is the ratio of the Population growth (in %) in Papua New Guinea in 1976 to that in 1982?
Give a very brief answer. 1.11. What is the ratio of the Population growth (in %) in Pacific island small states in 1976 to that in 1983?
Offer a terse response. 0.91. What is the ratio of the Population growth (in %) of Small states in 1976 to that in 1983?
Give a very brief answer. 1.05. What is the ratio of the Population growth (in %) in Papua New Guinea in 1976 to that in 1983?
Offer a very short reply. 1.11. What is the ratio of the Population growth (in %) of Pacific island small states in 1977 to that in 1978?
Provide a short and direct response. 1.01. What is the ratio of the Population growth (in %) in Small states in 1977 to that in 1978?
Offer a very short reply. 1.01. What is the ratio of the Population growth (in %) in Papua New Guinea in 1977 to that in 1978?
Make the answer very short. 1.01. What is the ratio of the Population growth (in %) in United Kingdom in 1977 to that in 1978?
Provide a short and direct response. 0.83. What is the ratio of the Population growth (in %) in Pacific island small states in 1977 to that in 1979?
Offer a very short reply. 0.98. What is the ratio of the Population growth (in %) in Small states in 1977 to that in 1979?
Your response must be concise. 0.99. What is the ratio of the Population growth (in %) in Papua New Guinea in 1977 to that in 1979?
Provide a succinct answer. 1.01. What is the ratio of the Population growth (in %) in United Kingdom in 1977 to that in 1979?
Offer a very short reply. 0.59. What is the ratio of the Population growth (in %) of Pacific island small states in 1977 to that in 1980?
Your answer should be very brief. 0.93. What is the ratio of the Population growth (in %) in Small states in 1977 to that in 1980?
Your response must be concise. 0.96. What is the ratio of the Population growth (in %) in United Kingdom in 1977 to that in 1980?
Provide a short and direct response. 0.54. What is the ratio of the Population growth (in %) in Pacific island small states in 1977 to that in 1981?
Give a very brief answer. 0.85. What is the ratio of the Population growth (in %) of Small states in 1977 to that in 1981?
Give a very brief answer. 1.02. What is the ratio of the Population growth (in %) of Papua New Guinea in 1977 to that in 1981?
Give a very brief answer. 1.07. What is the ratio of the Population growth (in %) of United Kingdom in 1977 to that in 1981?
Your answer should be very brief. 1.02. What is the ratio of the Population growth (in %) in Pacific island small states in 1977 to that in 1982?
Your answer should be compact. 0.81. What is the ratio of the Population growth (in %) of Papua New Guinea in 1977 to that in 1982?
Provide a succinct answer. 1.09. What is the ratio of the Population growth (in %) of Pacific island small states in 1977 to that in 1983?
Offer a terse response. 0.82. What is the ratio of the Population growth (in %) in Small states in 1977 to that in 1983?
Your answer should be compact. 1.01. What is the ratio of the Population growth (in %) of Papua New Guinea in 1977 to that in 1983?
Provide a short and direct response. 1.09. What is the ratio of the Population growth (in %) in Pacific island small states in 1978 to that in 1979?
Your response must be concise. 0.96. What is the ratio of the Population growth (in %) in Small states in 1978 to that in 1979?
Your response must be concise. 0.98. What is the ratio of the Population growth (in %) of Papua New Guinea in 1978 to that in 1979?
Provide a succinct answer. 1. What is the ratio of the Population growth (in %) in United Kingdom in 1978 to that in 1979?
Provide a short and direct response. 0.71. What is the ratio of the Population growth (in %) in Pacific island small states in 1978 to that in 1980?
Keep it short and to the point. 0.92. What is the ratio of the Population growth (in %) in Small states in 1978 to that in 1980?
Provide a short and direct response. 0.95. What is the ratio of the Population growth (in %) in United Kingdom in 1978 to that in 1980?
Your answer should be compact. 0.65. What is the ratio of the Population growth (in %) in Pacific island small states in 1978 to that in 1981?
Provide a short and direct response. 0.84. What is the ratio of the Population growth (in %) in Small states in 1978 to that in 1981?
Your response must be concise. 1.01. What is the ratio of the Population growth (in %) of Papua New Guinea in 1978 to that in 1981?
Offer a very short reply. 1.06. What is the ratio of the Population growth (in %) of United Kingdom in 1978 to that in 1981?
Provide a succinct answer. 1.22. What is the ratio of the Population growth (in %) of Pacific island small states in 1978 to that in 1982?
Offer a very short reply. 0.8. What is the ratio of the Population growth (in %) of Small states in 1978 to that in 1982?
Offer a very short reply. 0.99. What is the ratio of the Population growth (in %) of Papua New Guinea in 1978 to that in 1982?
Your answer should be compact. 1.08. What is the ratio of the Population growth (in %) in Pacific island small states in 1978 to that in 1983?
Offer a very short reply. 0.81. What is the ratio of the Population growth (in %) of Papua New Guinea in 1978 to that in 1983?
Provide a succinct answer. 1.09. What is the ratio of the Population growth (in %) of Pacific island small states in 1979 to that in 1980?
Offer a very short reply. 0.95. What is the ratio of the Population growth (in %) of Small states in 1979 to that in 1980?
Give a very brief answer. 0.97. What is the ratio of the Population growth (in %) in United Kingdom in 1979 to that in 1980?
Your response must be concise. 0.91. What is the ratio of the Population growth (in %) of Pacific island small states in 1979 to that in 1981?
Offer a terse response. 0.87. What is the ratio of the Population growth (in %) of Small states in 1979 to that in 1981?
Give a very brief answer. 1.03. What is the ratio of the Population growth (in %) in Papua New Guinea in 1979 to that in 1981?
Offer a terse response. 1.06. What is the ratio of the Population growth (in %) in United Kingdom in 1979 to that in 1981?
Make the answer very short. 1.71. What is the ratio of the Population growth (in %) of Pacific island small states in 1979 to that in 1982?
Provide a succinct answer. 0.83. What is the ratio of the Population growth (in %) in Small states in 1979 to that in 1982?
Offer a very short reply. 1.01. What is the ratio of the Population growth (in %) in Papua New Guinea in 1979 to that in 1982?
Offer a terse response. 1.08. What is the ratio of the Population growth (in %) of Pacific island small states in 1979 to that in 1983?
Your answer should be compact. 0.84. What is the ratio of the Population growth (in %) in Small states in 1979 to that in 1983?
Your response must be concise. 1.03. What is the ratio of the Population growth (in %) of Papua New Guinea in 1979 to that in 1983?
Your answer should be compact. 1.08. What is the ratio of the Population growth (in %) of Pacific island small states in 1980 to that in 1981?
Keep it short and to the point. 0.92. What is the ratio of the Population growth (in %) of Small states in 1980 to that in 1981?
Ensure brevity in your answer.  1.06. What is the ratio of the Population growth (in %) of Papua New Guinea in 1980 to that in 1981?
Provide a succinct answer. 1.06. What is the ratio of the Population growth (in %) in United Kingdom in 1980 to that in 1981?
Offer a terse response. 1.88. What is the ratio of the Population growth (in %) of Pacific island small states in 1980 to that in 1982?
Keep it short and to the point. 0.88. What is the ratio of the Population growth (in %) in Small states in 1980 to that in 1982?
Provide a succinct answer. 1.04. What is the ratio of the Population growth (in %) of Papua New Guinea in 1980 to that in 1982?
Your answer should be very brief. 1.08. What is the ratio of the Population growth (in %) of Pacific island small states in 1980 to that in 1983?
Provide a succinct answer. 0.88. What is the ratio of the Population growth (in %) in Small states in 1980 to that in 1983?
Ensure brevity in your answer.  1.06. What is the ratio of the Population growth (in %) of Papua New Guinea in 1980 to that in 1983?
Offer a terse response. 1.09. What is the ratio of the Population growth (in %) of Pacific island small states in 1981 to that in 1982?
Keep it short and to the point. 0.96. What is the ratio of the Population growth (in %) of Small states in 1981 to that in 1982?
Your answer should be very brief. 0.97. What is the ratio of the Population growth (in %) of Papua New Guinea in 1981 to that in 1982?
Keep it short and to the point. 1.02. What is the ratio of the Population growth (in %) of Pacific island small states in 1981 to that in 1983?
Give a very brief answer. 0.96. What is the ratio of the Population growth (in %) in Papua New Guinea in 1981 to that in 1983?
Ensure brevity in your answer.  1.02. What is the ratio of the Population growth (in %) in Pacific island small states in 1982 to that in 1983?
Provide a succinct answer. 1.01. What is the ratio of the Population growth (in %) in Papua New Guinea in 1982 to that in 1983?
Make the answer very short. 1. What is the difference between the highest and the second highest Population growth (in %) of Pacific island small states?
Keep it short and to the point. 0.03. What is the difference between the highest and the second highest Population growth (in %) of Small states?
Ensure brevity in your answer.  0.03. What is the difference between the highest and the second highest Population growth (in %) of Papua New Guinea?
Offer a very short reply. 0.08. What is the difference between the highest and the second highest Population growth (in %) of United Kingdom?
Keep it short and to the point. 0.03. What is the difference between the highest and the lowest Population growth (in %) of Pacific island small states?
Ensure brevity in your answer.  0.63. What is the difference between the highest and the lowest Population growth (in %) in Small states?
Make the answer very short. 0.23. What is the difference between the highest and the lowest Population growth (in %) in Papua New Guinea?
Offer a very short reply. 0.46. What is the difference between the highest and the lowest Population growth (in %) in United Kingdom?
Provide a short and direct response. 0.32. 